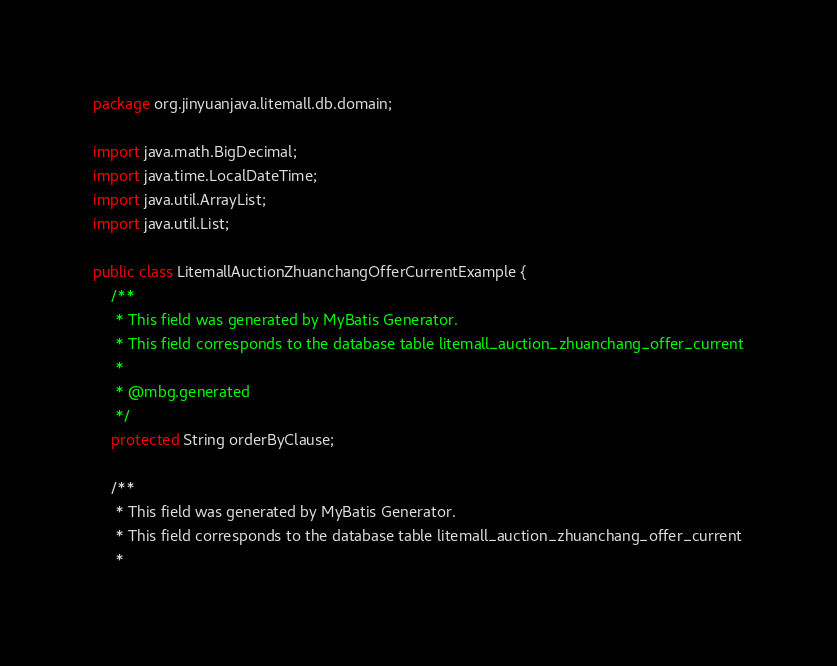Convert code to text. <code><loc_0><loc_0><loc_500><loc_500><_Java_>package org.jinyuanjava.litemall.db.domain;

import java.math.BigDecimal;
import java.time.LocalDateTime;
import java.util.ArrayList;
import java.util.List;

public class LitemallAuctionZhuanchangOfferCurrentExample {
    /**
     * This field was generated by MyBatis Generator.
     * This field corresponds to the database table litemall_auction_zhuanchang_offer_current
     *
     * @mbg.generated
     */
    protected String orderByClause;

    /**
     * This field was generated by MyBatis Generator.
     * This field corresponds to the database table litemall_auction_zhuanchang_offer_current
     *</code> 